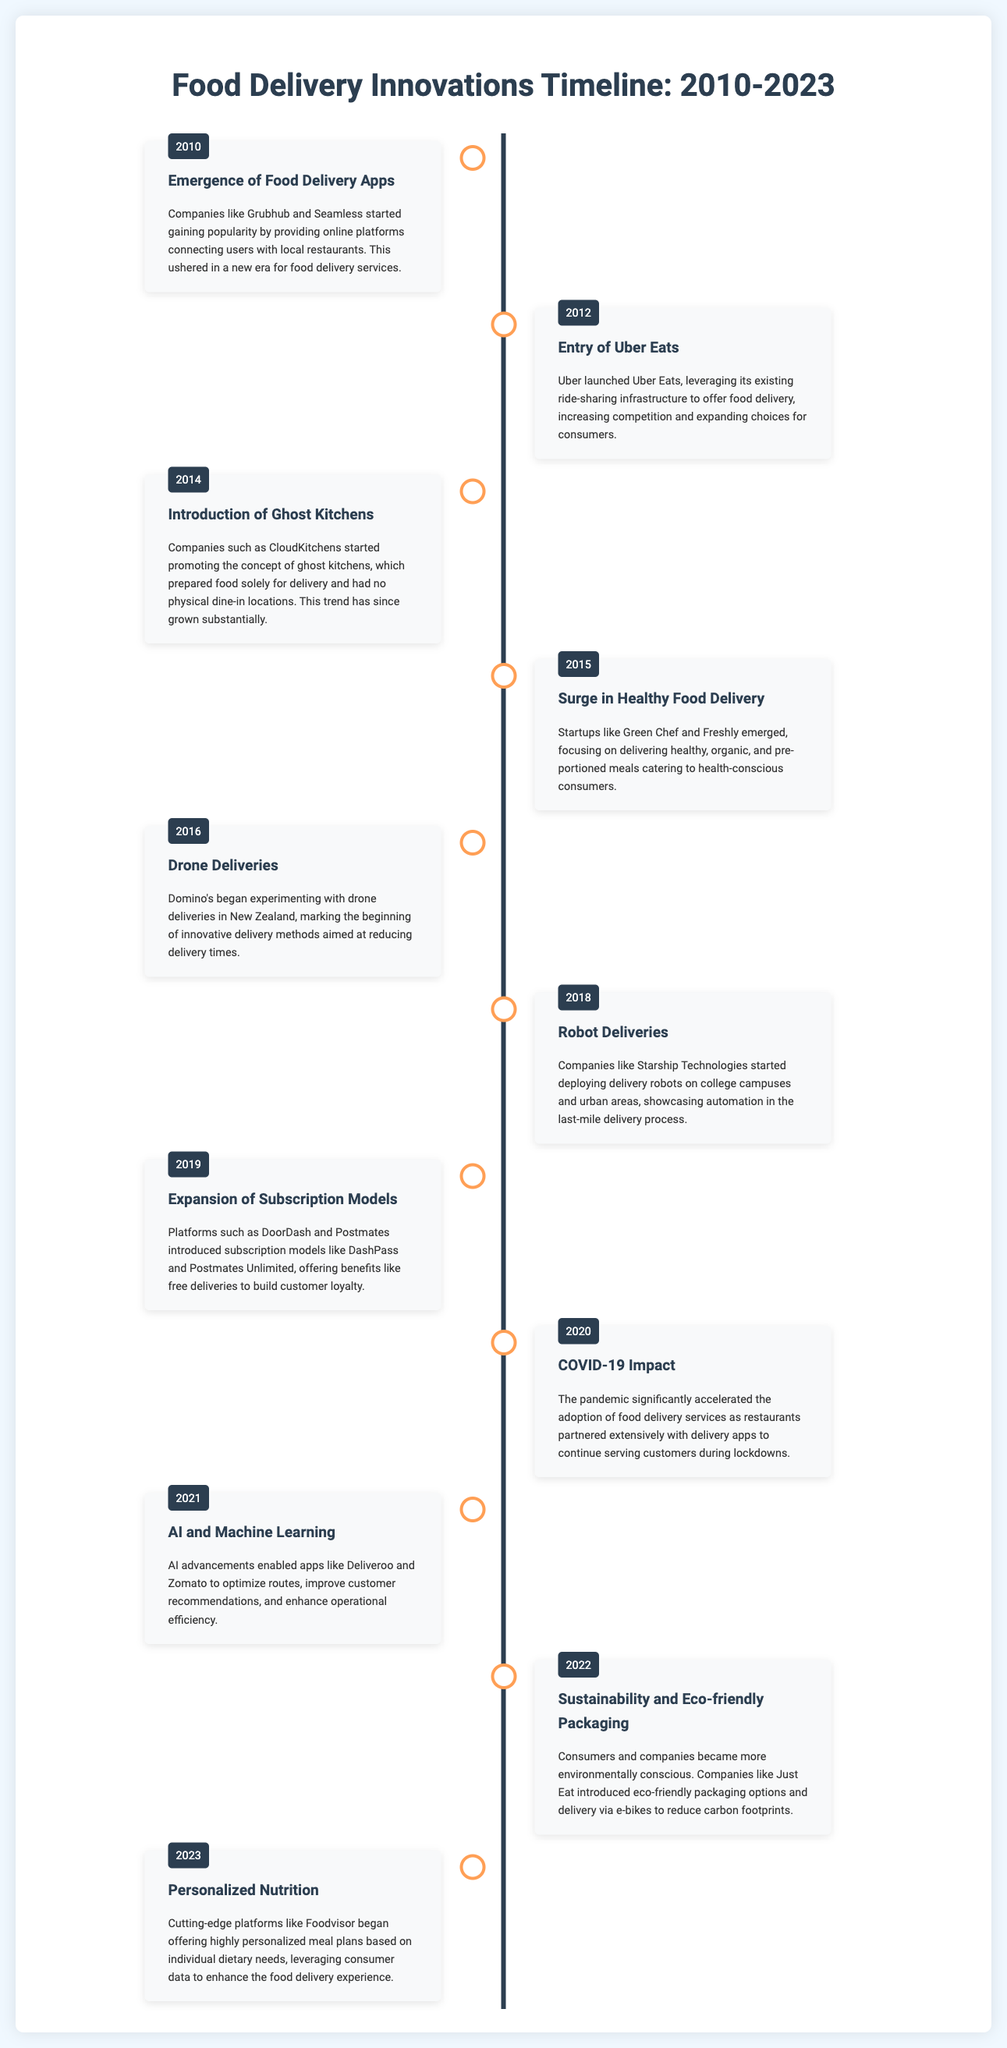What year did Uber Eats launch? Uber Eats entered the food delivery market in 2012, as mentioned in the document.
Answer: 2012 What is a key trend introduced in 2014? The document states that ghost kitchens were introduced in 2014, representing a major shift in food delivery strategy.
Answer: Ghost Kitchens Which company began experimenting with drone deliveries? The document specifies that Domino's started experimenting with drone deliveries in 2016.
Answer: Domino's How did the COVID-19 pandemic affect food delivery services? The document notes that the pandemic accelerated the adoption of food delivery services in 2020.
Answer: Accelerated adoption What innovative technology was introduced in 2021? AI and Machine Learning were emphasized as significant advancements in food delivery technology, as per the document.
Answer: AI and Machine Learning What delivery method was noted as being eco-friendly in 2022? The document mentions that companies introduced eco-friendly packaging options and delivery via e-bikes in 2022.
Answer: E-bikes Which delivery trend focuses on customer dietary needs in 2023? The document indicates that personalized nutrition platforms emerged in 2023 to cater to individual dietary requirements.
Answer: Personalized Nutrition What subscription model was introduced in 2019? Subscription models like DashPass and Postmates Unlimited were introduced in 2019 according to the document.
Answer: DashPass What company started deploying delivery robots? The document states that Starship Technologies began deploying delivery robots in 2018.
Answer: Starship Technologies 